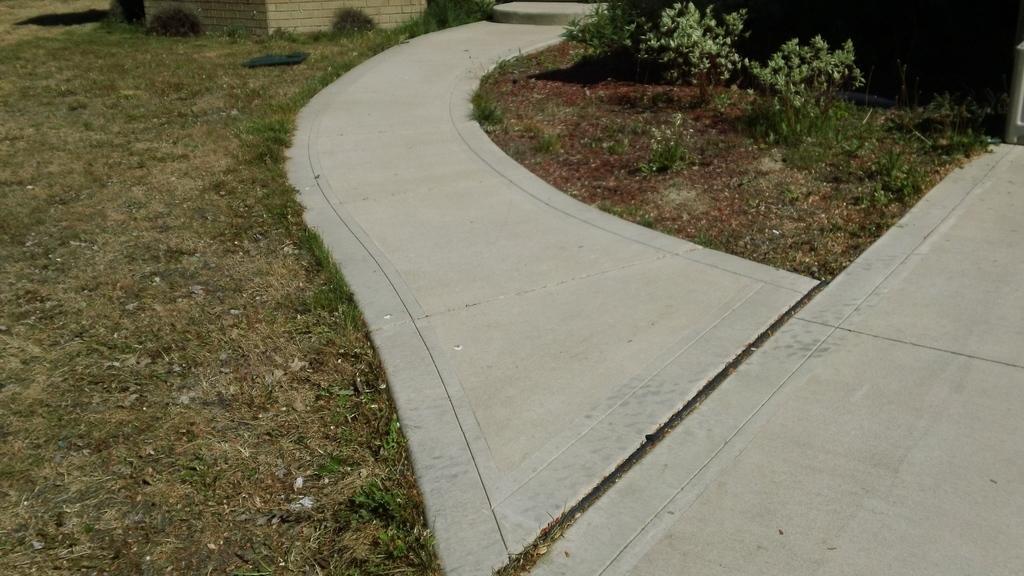Please provide a concise description of this image. In this picture we can see grass and few plants. 